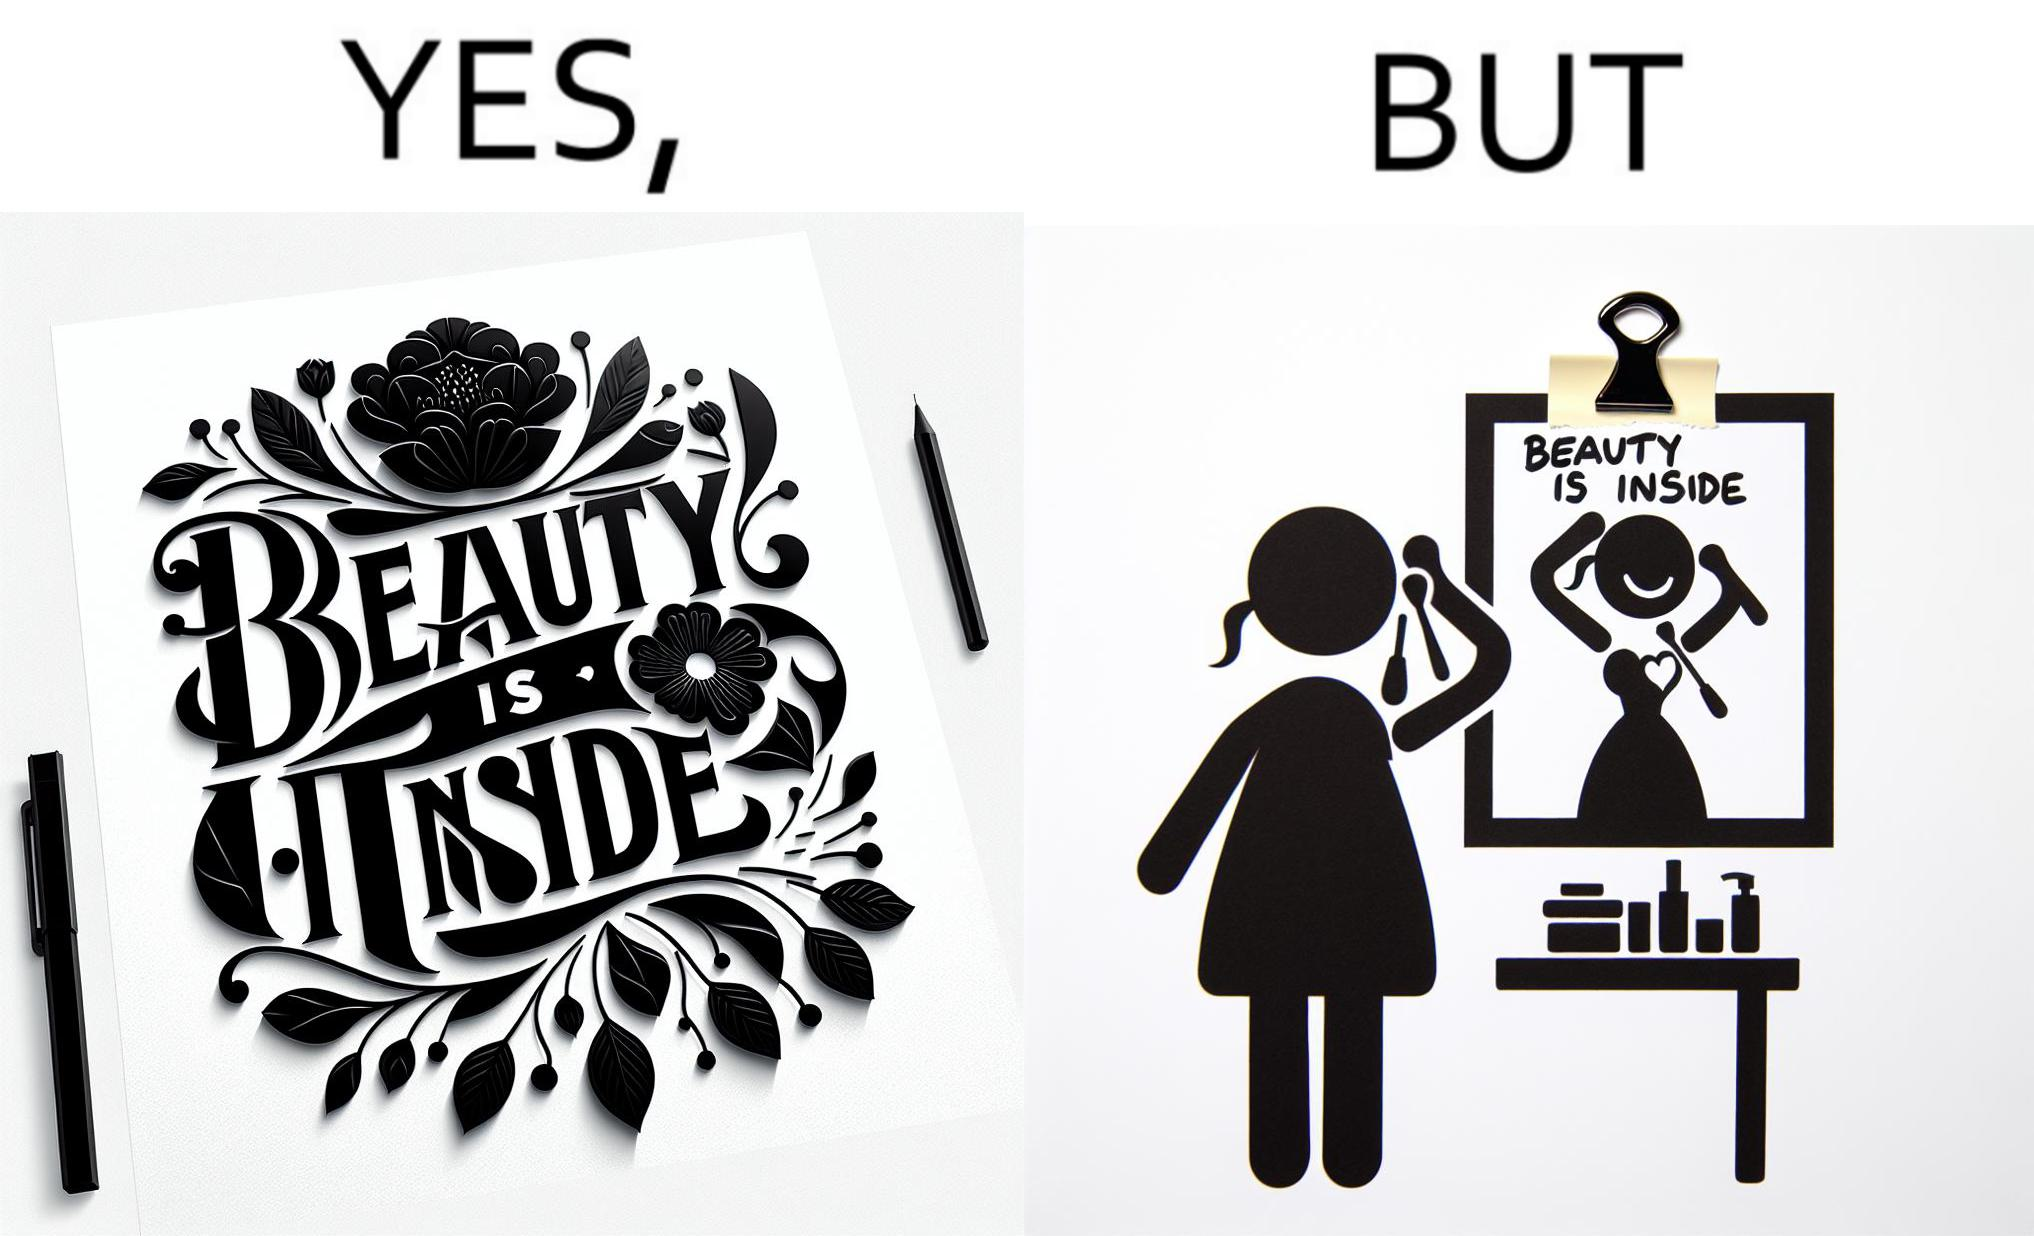Describe the content of this image. The image is satirical because while the text on the paper says that beauty lies inside, the woman ignores the note and continues to apply makeup to improve her outer beauty. 